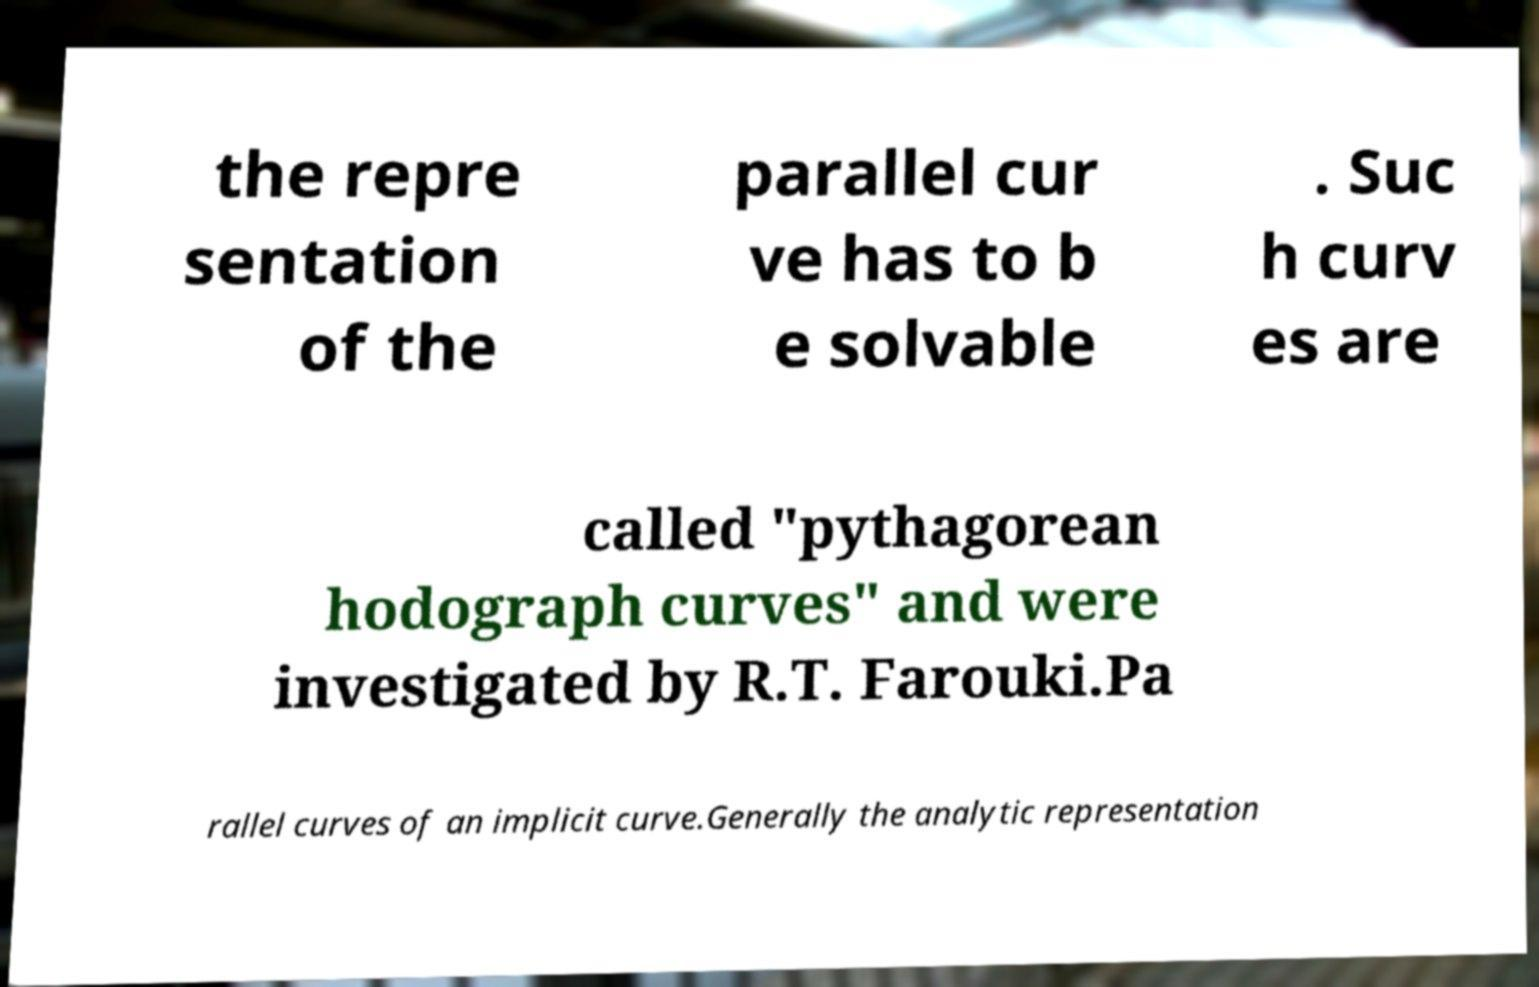Could you assist in decoding the text presented in this image and type it out clearly? the repre sentation of the parallel cur ve has to b e solvable . Suc h curv es are called "pythagorean hodograph curves" and were investigated by R.T. Farouki.Pa rallel curves of an implicit curve.Generally the analytic representation 